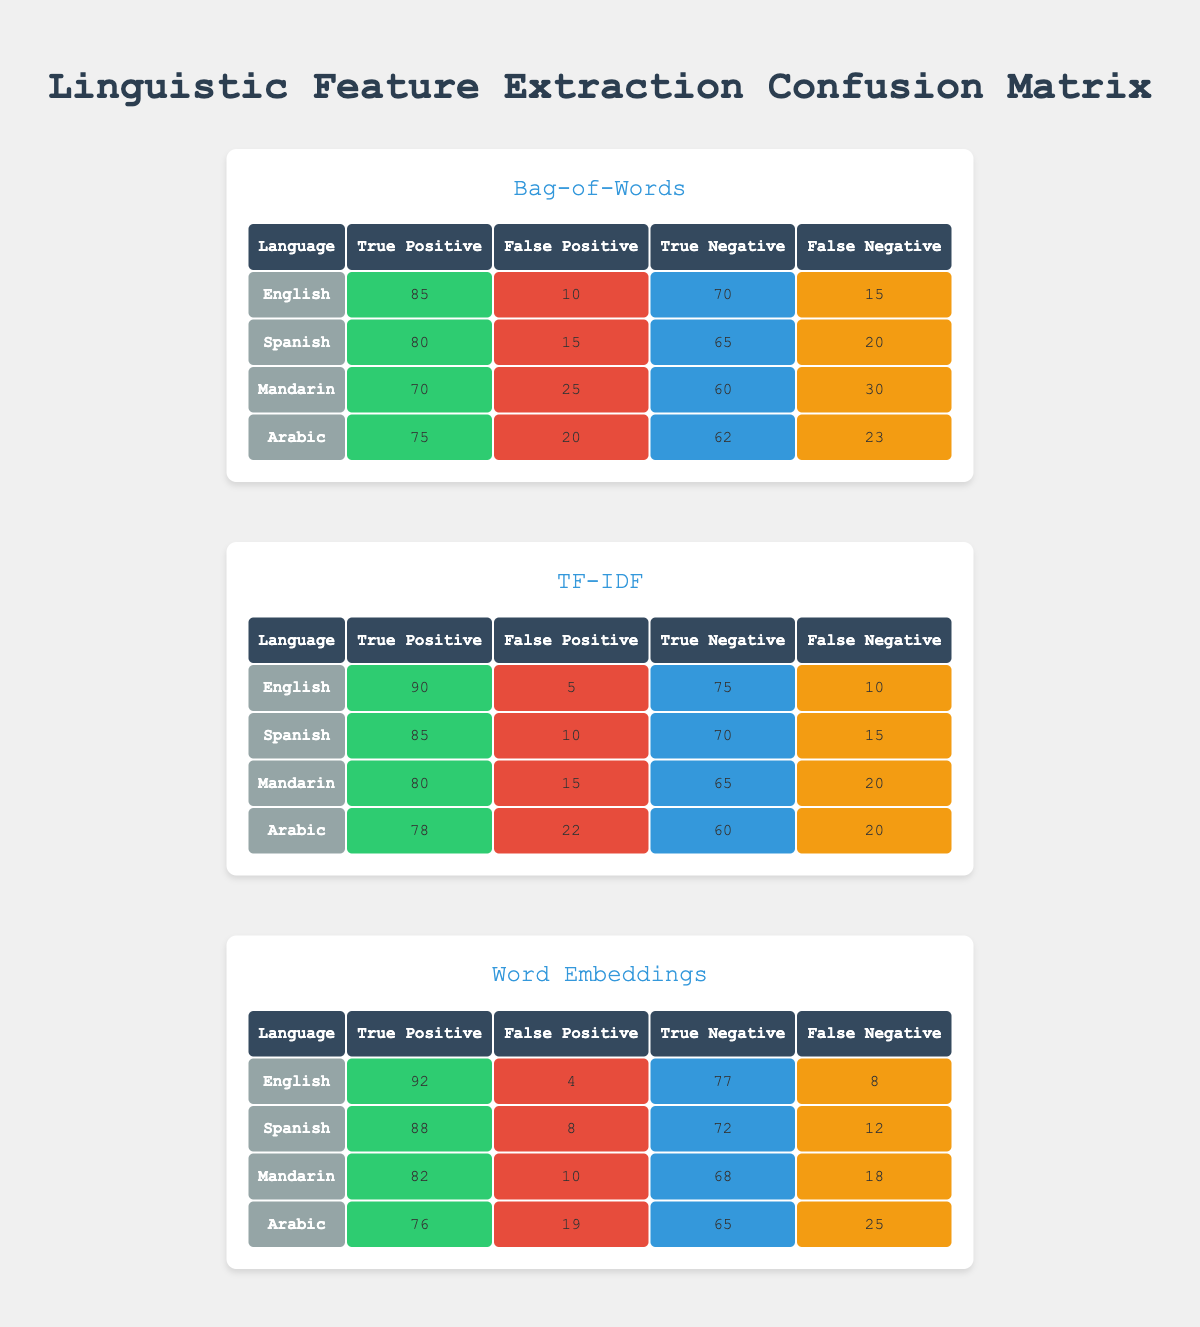What is the true positive value for Spanish using the Bag-of-Words method? The true positive value for Spanish with the Bag-of-Words method is listed in the corresponding row of the table. It shows a value of 80.
Answer: 80 Which methodology has the highest true positive rate for English? The highest true positive rate for English can be found by comparing the respective true positive values across the methodologies. Bag-of-Words shows 85, TF-IDF shows 90, and Word Embeddings shows 92; thus, Word Embeddings has the highest true positive rate for English.
Answer: Word Embeddings What is the total number of true positives across all languages for the TF-IDF method? The total true positives for TF-IDF can be calculated by adding the true positives for each language: 90 (English) + 85 (Spanish) + 80 (Mandarin) + 78 (Arabic) = 333.
Answer: 333 Is there a language where the false negative count is higher than the false positive count using Word Embeddings? To answer this, we will check each language's false negative and false positive counts for Word Embeddings. For English: 8 vs 4 (no), Spanish: 12 vs 8 (no), Mandarin: 18 vs 10 (no), Arabic: 25 vs 19 (yes). Thus, Arabic is the only one with a higher false negative count.
Answer: Yes What is the average true negative value across all languages for the Bag-of-Words method? To find the average, sum the true negative values for each language: 70 (English) + 65 (Spanish) + 60 (Mandarin) + 62 (Arabic) = 257; divide by 4 (the number of languages): 257 / 4 = 64.25.
Answer: 64.25 Which methodology had the lowest true positive rate for Mandarin? The true positives for Mandarin are 70 with Bag-of-Words, 80 with TF-IDF, and 82 with Word Embeddings. Therefore, the lowest true positive rate for Mandarin is from Bag-of-Words.
Answer: Bag-of-Words Does the TF-IDF method have a lower false positive rate than the Word Embeddings method for Spanish? We compare the false positive counts for both methodologies. TF-IDF has 10, while Word Embeddings has 8 for Spanish. Since 10 is greater than 8, TF-IDF does not have a lower false positive rate.
Answer: No What is the difference in true positive rates between the highest and lowest performing methodologies for Arabic? The true positive for Arabic in Bag-of-Words is 75, while in Word Embeddings it's 76. The difference between these is 76 - 75 = 1.
Answer: 1 